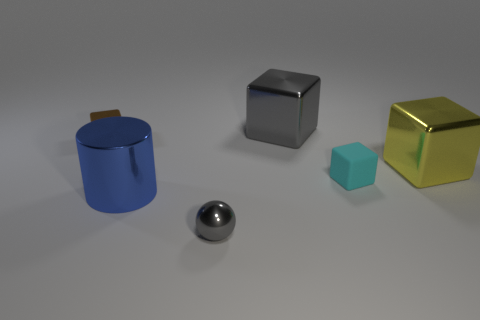Subtract all gray blocks. How many blocks are left? 3 Subtract all yellow cubes. How many cubes are left? 3 Add 3 metallic cylinders. How many objects exist? 9 Subtract all red cubes. Subtract all green balls. How many cubes are left? 4 Subtract all cubes. How many objects are left? 2 Subtract all blue cylinders. Subtract all small brown metallic cubes. How many objects are left? 4 Add 5 tiny balls. How many tiny balls are left? 6 Add 4 red metallic cubes. How many red metallic cubes exist? 4 Subtract 0 purple balls. How many objects are left? 6 